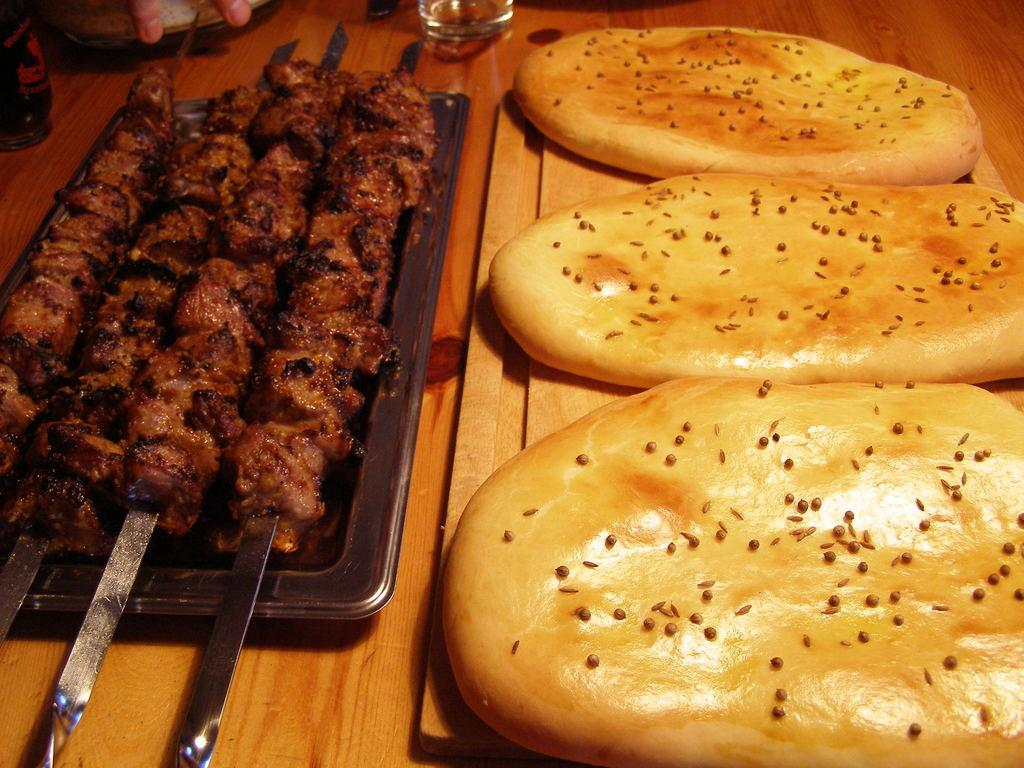What is on the plates in the image? There are food items on plates in the image. What material is the table made of? The table appears to be made of wood. What can be seen on the table besides the plates with food? There is a glass on the table. Are there any other objects on the table? Yes, there are other objects on the table. What type of flowers are growing on the table in the image? There are no flowers present on the table in the image. 